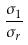<formula> <loc_0><loc_0><loc_500><loc_500>\frac { \sigma _ { 1 } } { \sigma _ { r } }</formula> 